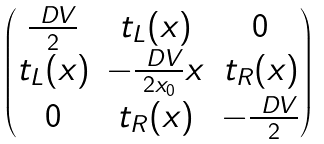<formula> <loc_0><loc_0><loc_500><loc_500>\begin{pmatrix} \frac { \ D V } { 2 } & t _ { L } ( x ) & 0 \\ t _ { L } ( x ) & - \frac { \ D V } { 2 x _ { 0 } } x & t _ { R } ( x ) \\ 0 & t _ { R } ( x ) & - \frac { \ D V } { 2 } \end{pmatrix}</formula> 